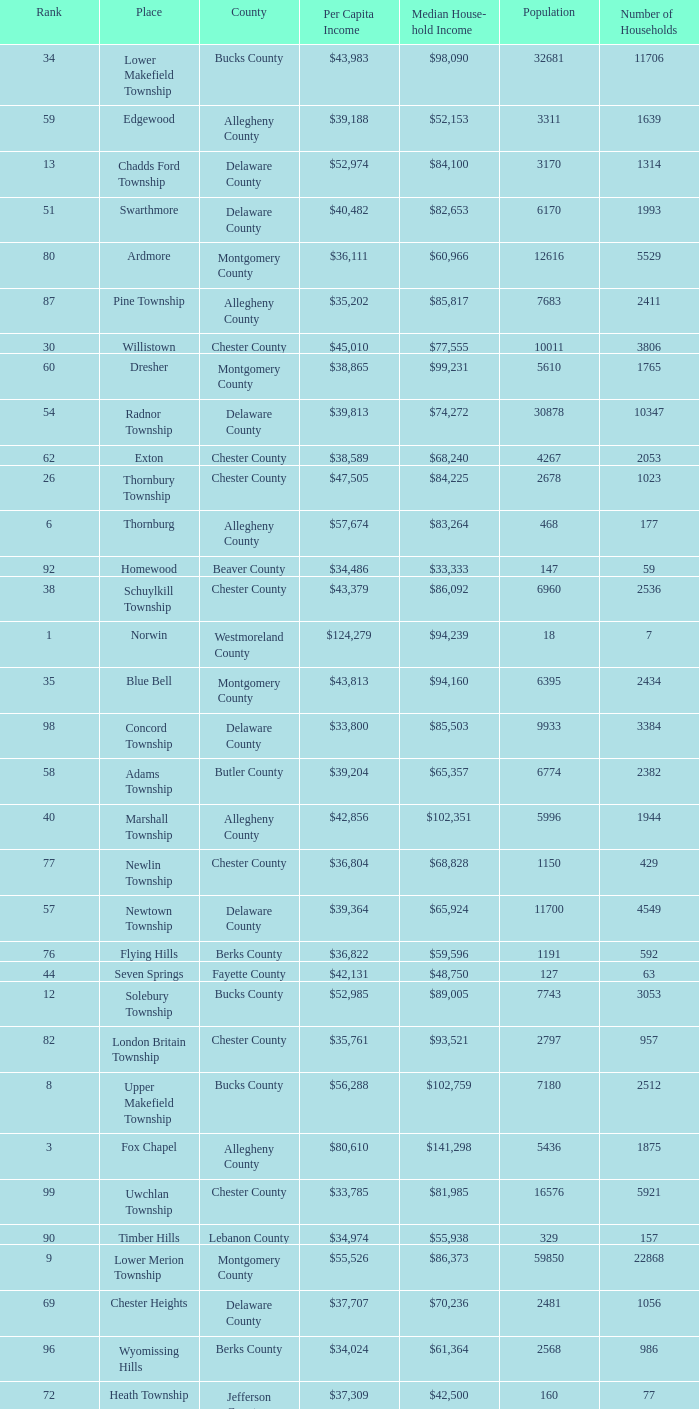What is the per capita income for Fayette County? $42,131. Write the full table. {'header': ['Rank', 'Place', 'County', 'Per Capita Income', 'Median House- hold Income', 'Population', 'Number of Households'], 'rows': [['34', 'Lower Makefield Township', 'Bucks County', '$43,983', '$98,090', '32681', '11706'], ['59', 'Edgewood', 'Allegheny County', '$39,188', '$52,153', '3311', '1639'], ['13', 'Chadds Ford Township', 'Delaware County', '$52,974', '$84,100', '3170', '1314'], ['51', 'Swarthmore', 'Delaware County', '$40,482', '$82,653', '6170', '1993'], ['80', 'Ardmore', 'Montgomery County', '$36,111', '$60,966', '12616', '5529'], ['87', 'Pine Township', 'Allegheny County', '$35,202', '$85,817', '7683', '2411'], ['30', 'Willistown', 'Chester County', '$45,010', '$77,555', '10011', '3806'], ['60', 'Dresher', 'Montgomery County', '$38,865', '$99,231', '5610', '1765'], ['54', 'Radnor Township', 'Delaware County', '$39,813', '$74,272', '30878', '10347'], ['62', 'Exton', 'Chester County', '$38,589', '$68,240', '4267', '2053'], ['26', 'Thornbury Township', 'Chester County', '$47,505', '$84,225', '2678', '1023'], ['6', 'Thornburg', 'Allegheny County', '$57,674', '$83,264', '468', '177'], ['92', 'Homewood', 'Beaver County', '$34,486', '$33,333', '147', '59'], ['38', 'Schuylkill Township', 'Chester County', '$43,379', '$86,092', '6960', '2536'], ['1', 'Norwin', 'Westmoreland County', '$124,279', '$94,239', '18', '7'], ['35', 'Blue Bell', 'Montgomery County', '$43,813', '$94,160', '6395', '2434'], ['98', 'Concord Township', 'Delaware County', '$33,800', '$85,503', '9933', '3384'], ['58', 'Adams Township', 'Butler County', '$39,204', '$65,357', '6774', '2382'], ['40', 'Marshall Township', 'Allegheny County', '$42,856', '$102,351', '5996', '1944'], ['77', 'Newlin Township', 'Chester County', '$36,804', '$68,828', '1150', '429'], ['57', 'Newtown Township', 'Delaware County', '$39,364', '$65,924', '11700', '4549'], ['76', 'Flying Hills', 'Berks County', '$36,822', '$59,596', '1191', '592'], ['44', 'Seven Springs', 'Fayette County', '$42,131', '$48,750', '127', '63'], ['12', 'Solebury Township', 'Bucks County', '$52,985', '$89,005', '7743', '3053'], ['82', 'London Britain Township', 'Chester County', '$35,761', '$93,521', '2797', '957'], ['8', 'Upper Makefield Township', 'Bucks County', '$56,288', '$102,759', '7180', '2512'], ['3', 'Fox Chapel', 'Allegheny County', '$80,610', '$141,298', '5436', '1875'], ['99', 'Uwchlan Township', 'Chester County', '$33,785', '$81,985', '16576', '5921'], ['90', 'Timber Hills', 'Lebanon County', '$34,974', '$55,938', '329', '157'], ['9', 'Lower Merion Township', 'Montgomery County', '$55,526', '$86,373', '59850', '22868'], ['69', 'Chester Heights', 'Delaware County', '$37,707', '$70,236', '2481', '1056'], ['96', 'Wyomissing Hills', 'Berks County', '$34,024', '$61,364', '2568', '986'], ['72', 'Heath Township', 'Jefferson County', '$37,309', '$42,500', '160', '77'], ['88', 'Narberth', 'Montgomery County', '$35,165', '$60,408', '4233', '1904'], ['81', 'Clarks Green', 'Lackawanna County', '$35,975', '$61,250', '1630', '616'], ['66', 'Churchill', 'Allegheny County', '$37,964', '$67,321', '3566', '1519'], ['52', 'Lafayette Hill', 'Montgomery County', '$40,363', '$84,835', '10226', '3783'], ['49', 'Penn Wynne', 'Montgomery County', '$41,199', '$78,398', '5382', '2072'], ['85', 'North Abington Township', 'Lackawanna County', '$35,537', '$57,917', '782', '258'], ['24', 'Spring House', 'Montgomery County', '$47,661', '$89,000', '3290', '1347'], ['65', 'Upper Dublin Township', 'Montgomery County', '$37,994', '$80,093', '25878', '9174'], ['11', 'Haysville', 'Allegheny County', '$53,151', '$33,750', '78', '36'], ['32', 'Ben Avon Heights', 'Allegheny County', '$44,191', '$105,006', '392', '138'], ['29', 'New Hope', 'Bucks County', '$45,309', '$60,833', '2252', '1160'], ['43', 'Upper St.Clair Township', 'Allegheny County', '$42,413', '$87,581', '20053', '6966'], ['21', 'Osborne', 'Allegheny County', '$50,169', '$64,375', '566', '216'], ['75', 'Thompsonville', 'Washington County', '$36,853', '$75,000', '3592', '1228'], ['70', 'McMurray', 'Washington County', '$37,364', '$81,736', '4726', '1582'], ['18', 'Bradford Woods', 'Allegheny County', '$51,462', '$92,820', '1149', '464'], ['2', 'Gladwyne', 'Montgomery County', '$90,940', '$159,905', '4050', '1476'], ['37', 'Mount Gretna', 'Lebanon County', '$43,470', '$62,917', '242', '117'], ['71', 'Wyomissing', 'Berks County', '$37,313', '$54,681', '8587', '3359'], ['86', 'Malvern', 'Chester County', '$35,477', '$62,308', '3059', '1361'], ['45', 'Charlestown Township', 'Chester County', '$41,878', '$89,813', '4051', '1340'], ['95', 'Worcester Township', 'Montgomery County', '$34,264', '$77,200', '7789', '2896'], ['53', 'Lower Moreland Township', 'Montgomery County', '$40,129', '$82,597', '11281', '4112'], ['27', 'Edgmont Township', 'Delaware County', '$46,848', '$88,303', '3918', '1447'], ['84', 'Devon-Berwyn', 'Chester County', '$35,551', '$74,886', '5067', '1978'], ['7', 'Rosslyn Farms', 'Allegheny County', '$56,612', '$87,500', '464', '184'], ['74', 'Westtown Township', 'Chester County', '$36,894', '$85,049', '10352', '3705'], ['25', 'Tredyffrin Township', 'Chester County', '$47,584', '$82,258', '29062', '12223'], ['64', 'Doylestown Township', 'Bucks County', '$38,031', '$81,226', '17619', '5999'], ['56', 'Upper Providence Township', 'Delaware County', '$39,532', '$71,166', '10509', '4075'], ['33', 'Bala-Cynwyd', 'Montgomery County', '$44,027', '$78,932', '9336', '3726'], ['28', 'Kennett Township', 'Chester County', '$46,669', '$85,104', '6451', '2457'], ['14', 'Pennsbury Township', 'Chester County', '$52,530', '$83,295', '3500', '1387'], ['16', 'Chesterbrook', 'Chester County', '$51,859', '$80,792', '4625', '2356'], ['55', 'Whitemarsh Township', 'Montgomery County', '$39,785', '$78,630', '16702', '6179'], ['89', 'West Whiteland Township', 'Chester County', '$35,031', '$71,545', '16499', '6618'], ['39', 'Fort Washington', 'Montgomery County', '$43,090', '$103,469', '3680', '1161'], ['4', 'Sewickley Heights', 'Allegheny County', '$74,346', '$115,672', '981', '336'], ['67', 'Franklin Park', 'Allegheny County', '$37,924', '$87,627', '11364', '3866'], ['50', 'East Bradford Township', 'Chester County', '$41,158', '$100,732', '9405', '3076'], ['91', 'Upper Merion Township', 'Montgomery County', '$34,961', '$65,636', '26863', '11575'], ['22', 'West Pikeland Township', 'Chester County', '$48,616', '$105,322', '3551', '1214'], ['93', 'Newtown Township', 'Bucks County', '$34,335', '$80,532', '18206', '6761'], ['94', 'Tinicum Township', 'Bucks County', '$34,321', '$60,843', '4206', '1674'], ['47', 'Whitpain Township', 'Montgomery County', '$41,739', '$88,933', '18562', '6960'], ['73', 'Aleppo Township', 'Allegheny County', '$37,187', '$59,167', '1039', '483'], ['23', 'Spring Ridge', 'Berks County', '$47,822', '$83,345', '786', '370'], ['5', 'Edgeworth', 'Allegheny County', '$69,350', '$99,144', '1730', '644'], ['61', 'Sewickley Hills', 'Allegheny County', '$38,681', '$79,466', '652', '225'], ['15', 'Pocopson Township', 'Chester County', '$51,883', '$98,215', '3350', '859'], ['19', 'Easttown Township', 'Chester County', '$51,028', '$95,548', '10270', '3758'], ['97', 'Woodbourne', 'Bucks County', '$33,821', '$107,913', '3512', '1008'], ['68', 'East Goshen Township', 'Chester County', '$37,775', '$64,777', '16824', '7165'], ['78', 'Wyndmoor', 'Montgomery County', '$36,205', '$72,219', '5601', '2144'], ['10', 'Rose Valley', 'Delaware County', '$54,202', '$114,373', '944', '347'], ['79', 'Peters Township', 'Washington County', '$36,159', '$77,442', '17566', '6026'], ['63', 'East Marlborough Township', 'Chester County', '$38,090', '$95,812', '6317', '2131'], ['42', 'Wrightstown Township', 'Bucks County', '$42,623', '$82,875', '2839', '971'], ['83', 'Buckingham Township', 'Bucks County', '$35,735', '$82,376', '16422', '5711'], ['17', 'Birmingham Township', 'Chester County', '$51,756', '$130,096', '4221', '1391'], ['36', 'West Vincent Township', 'Chester County', '$43,500', '$92,024', '3170', '1077'], ['48', 'Bell Acres', 'Allegheny County', '$41,202', '$61,094', '1382', '520'], ['20', 'Villanova', 'Montgomery County', '$50,204', '$159,538', '9060', '1902'], ['46', 'Lower Gwynedd Township', 'Montgomery County', '$41,868', '$74,351', '10422', '4177'], ['31', 'Abington Township', 'Lackawanna County', '$44,551', '$73,611', '1616', '609'], ['41', 'Woodside', 'Bucks County', '$42,653', '$121,151', '2575', '791']]} 